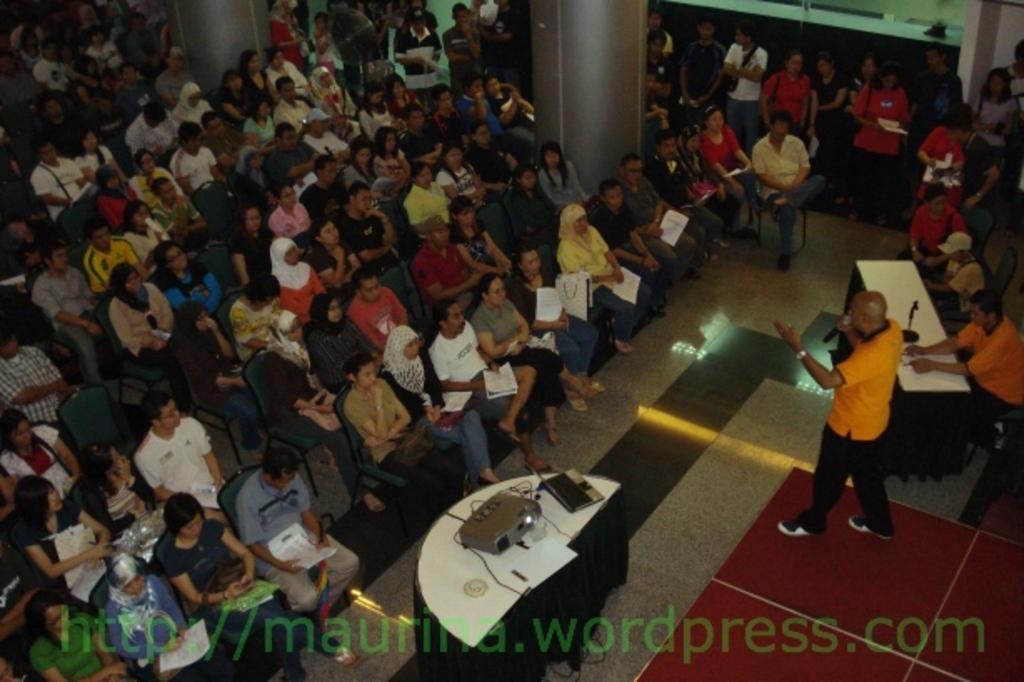Could you give a brief overview of what you see in this image? On the right we can see people, table, stage, person and and other objects. In the foreground there is a table, on the table we can see cables, projector screen and other objects. In this picture we can see people, chairs, pillars and other objects. 